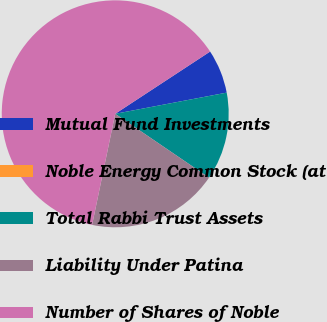Convert chart to OTSL. <chart><loc_0><loc_0><loc_500><loc_500><pie_chart><fcel>Mutual Fund Investments<fcel>Noble Energy Common Stock (at<fcel>Total Rabbi Trust Assets<fcel>Liability Under Patina<fcel>Number of Shares of Noble<nl><fcel>6.25%<fcel>0.0%<fcel>12.5%<fcel>18.75%<fcel>62.49%<nl></chart> 